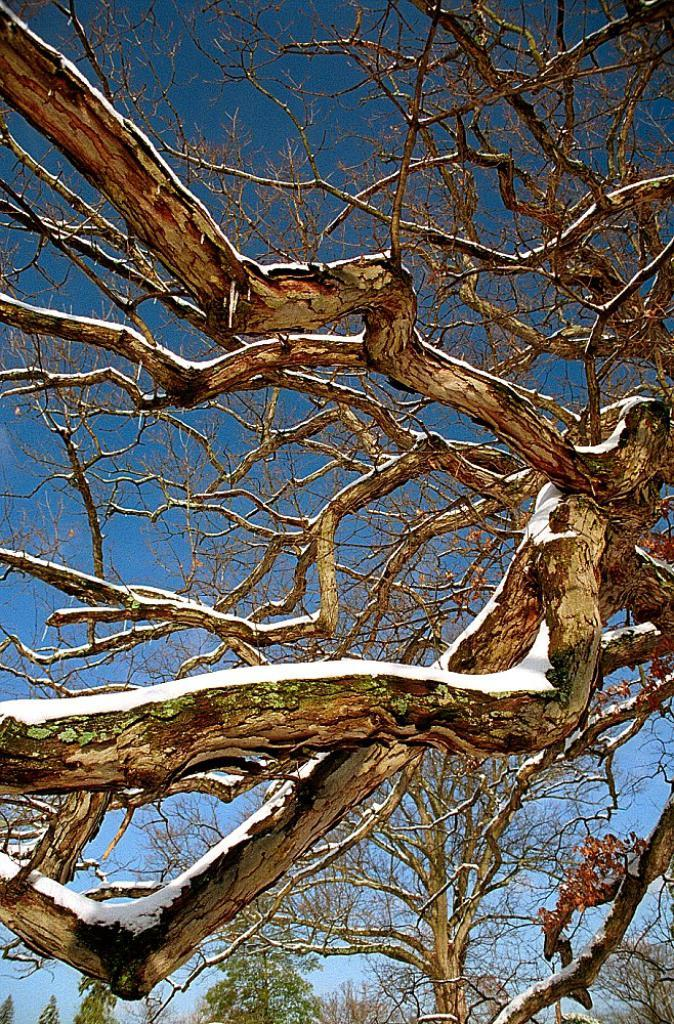What is the main subject in the middle of the image? There is a dry tree with branches in the middle of the image. What can be seen in the background of the image? The sky is blue and visible in the background of the image. What type of apple is the minister holding in the image? There is no minister or apple present in the image; it features a dry tree with branches and a blue sky in the background. Is there a stick used to stir the branches of the tree in the image? There is no stick present in the image; it only features a dry tree with branches and a blue sky in the background. 